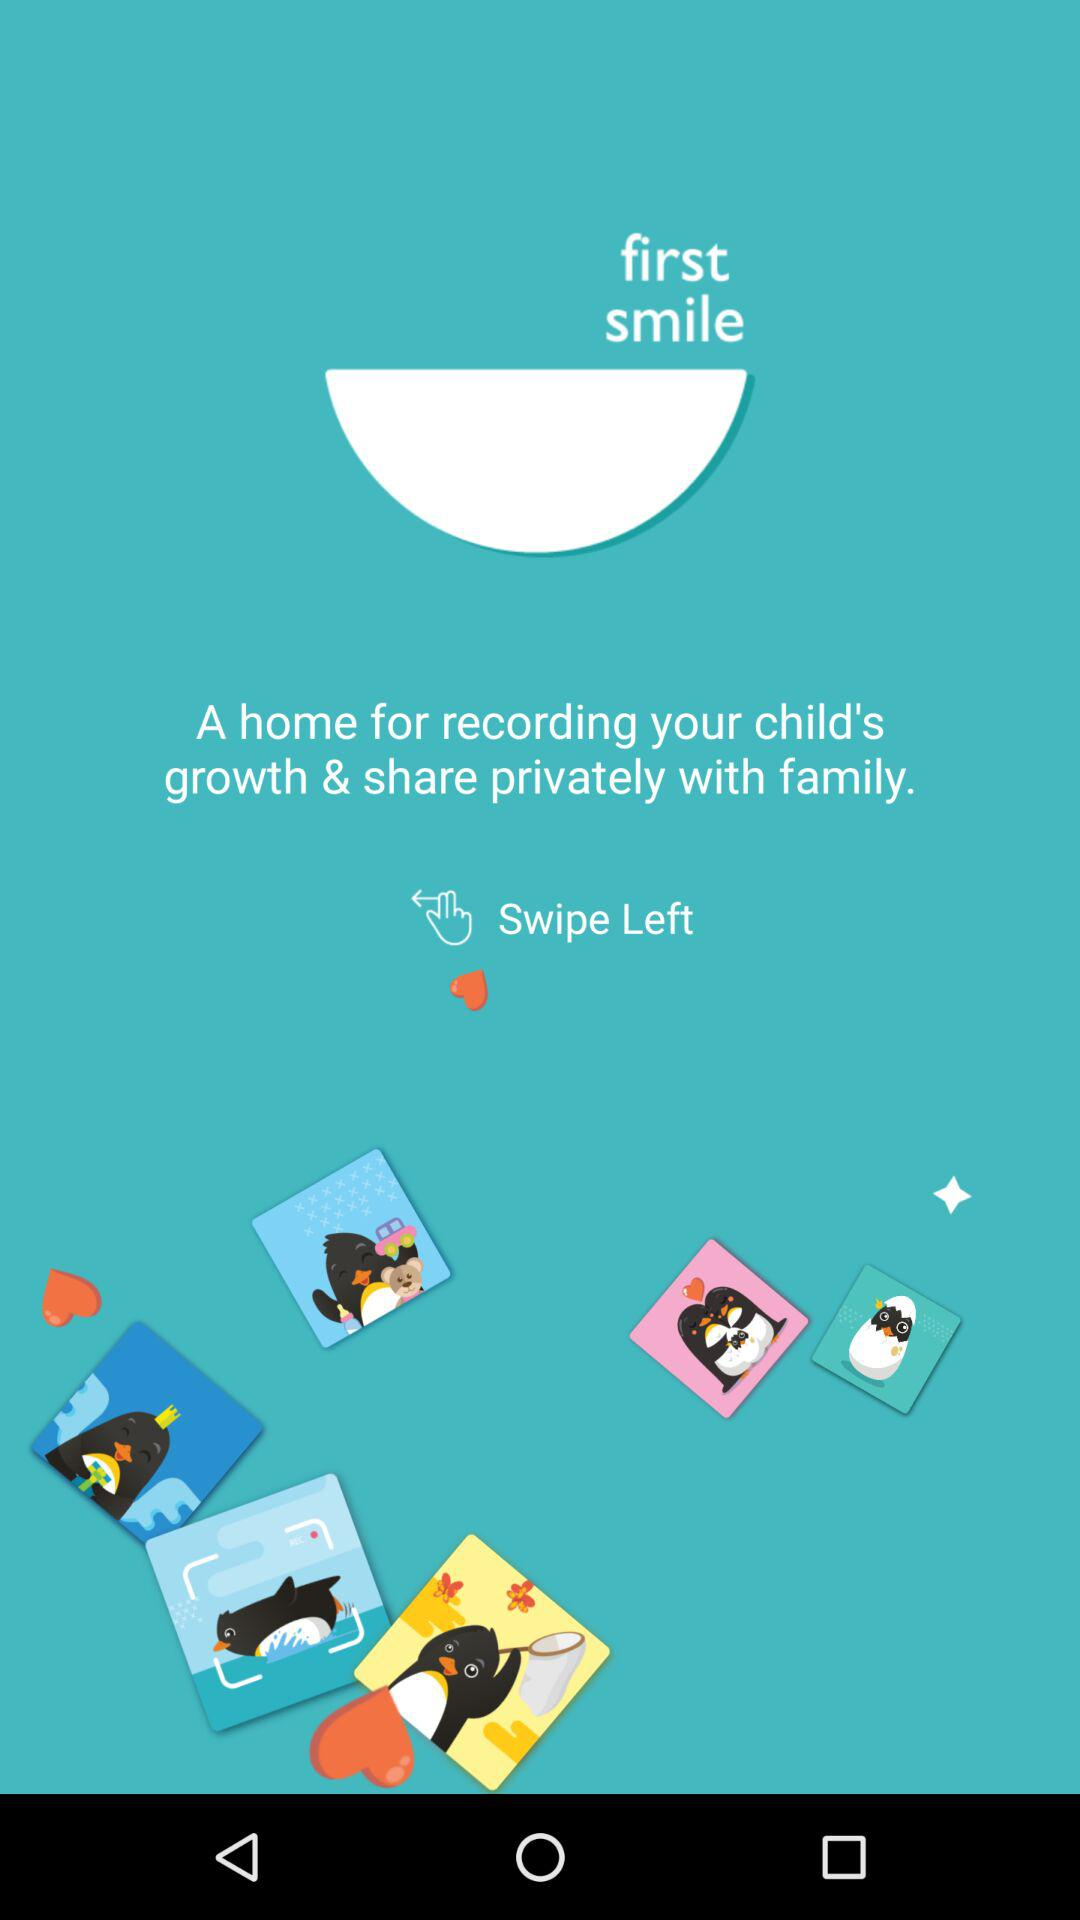What is the name of the application? The name of the application is "first smile". 